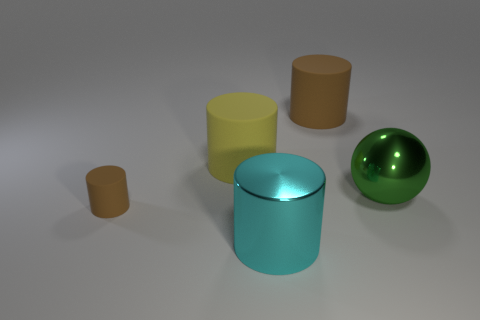How many rubber objects are to the right of the rubber cylinder to the right of the big cyan metal thing?
Your answer should be very brief. 0. How many cylinders are big green things or rubber things?
Your response must be concise. 3. What color is the matte cylinder that is behind the small brown thing and on the left side of the large brown rubber cylinder?
Your answer should be compact. Yellow. Are there any other things of the same color as the big metallic cylinder?
Your answer should be very brief. No. There is a big matte thing that is on the left side of the metal cylinder in front of the big yellow rubber object; what color is it?
Offer a very short reply. Yellow. Is the size of the yellow cylinder the same as the green object?
Keep it short and to the point. Yes. Is the material of the brown cylinder behind the tiny rubber thing the same as the brown cylinder that is in front of the big brown cylinder?
Your answer should be very brief. Yes. There is a large shiny thing that is on the right side of the shiny object in front of the cylinder to the left of the yellow cylinder; what shape is it?
Keep it short and to the point. Sphere. Are there more green metal spheres than cyan matte objects?
Ensure brevity in your answer.  Yes. Are any big cyan matte balls visible?
Give a very brief answer. No. 